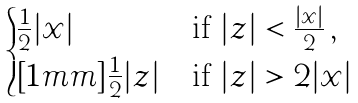Convert formula to latex. <formula><loc_0><loc_0><loc_500><loc_500>\begin{cases} \frac { 1 } { 2 } | x | & \text {if } | z | < \frac { | x | } 2 \, , \\ [ 1 m m ] \frac { 1 } { 2 } | z | & \text {if } | z | > 2 | x | \end{cases}</formula> 